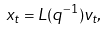Convert formula to latex. <formula><loc_0><loc_0><loc_500><loc_500>x _ { t } = L ( q ^ { - 1 } ) v _ { t } ,</formula> 